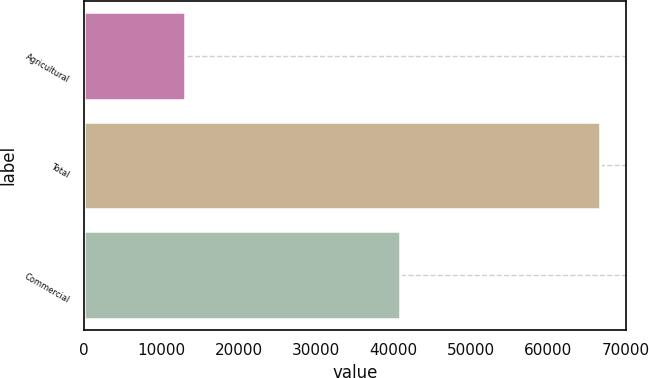Convert chart to OTSL. <chart><loc_0><loc_0><loc_500><loc_500><bar_chart><fcel>Agricultural<fcel>Total<fcel>Commercial<nl><fcel>13120<fcel>66678<fcel>40913<nl></chart> 